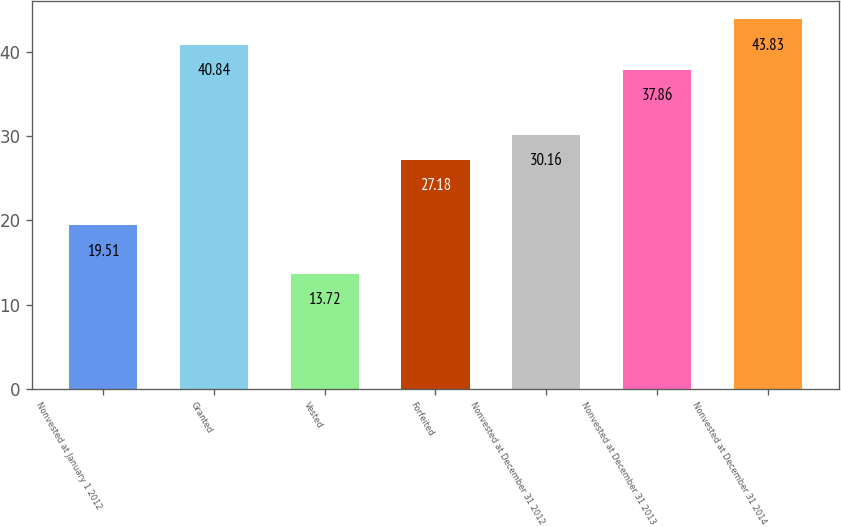<chart> <loc_0><loc_0><loc_500><loc_500><bar_chart><fcel>Nonvested at January 1 2012<fcel>Granted<fcel>Vested<fcel>Forfeited<fcel>Nonvested at December 31 2012<fcel>Nonvested at December 31 2013<fcel>Nonvested at December 31 2014<nl><fcel>19.51<fcel>40.84<fcel>13.72<fcel>27.18<fcel>30.16<fcel>37.86<fcel>43.83<nl></chart> 